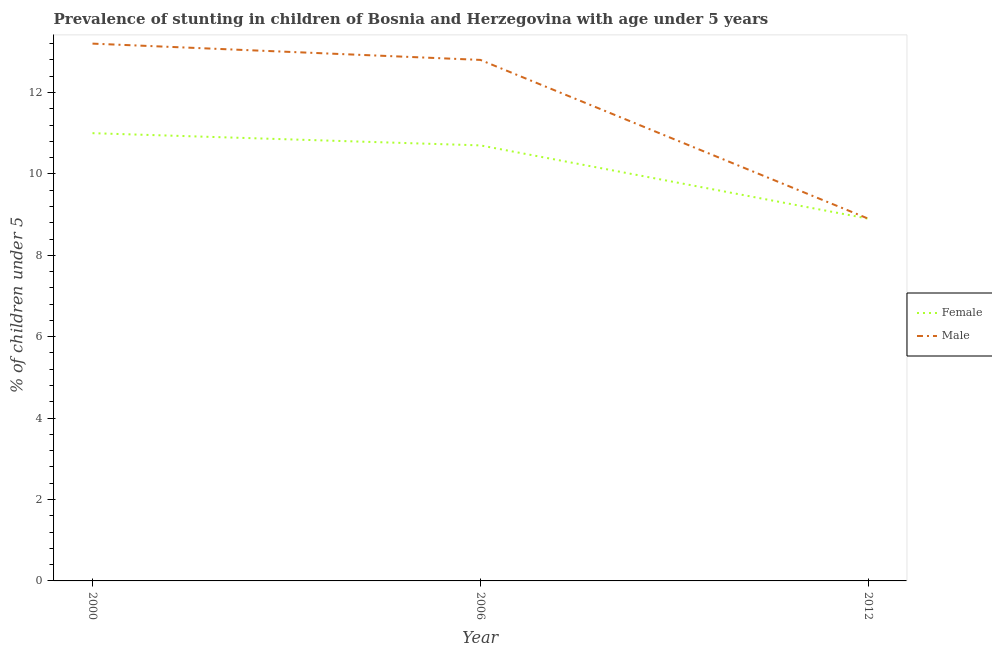Is the number of lines equal to the number of legend labels?
Provide a short and direct response. Yes. What is the percentage of stunted male children in 2012?
Provide a succinct answer. 8.9. Across all years, what is the maximum percentage of stunted male children?
Your answer should be compact. 13.2. Across all years, what is the minimum percentage of stunted male children?
Give a very brief answer. 8.9. In which year was the percentage of stunted female children minimum?
Ensure brevity in your answer.  2012. What is the total percentage of stunted male children in the graph?
Keep it short and to the point. 34.9. What is the difference between the percentage of stunted female children in 2000 and that in 2006?
Make the answer very short. 0.3. What is the difference between the percentage of stunted female children in 2012 and the percentage of stunted male children in 2000?
Your response must be concise. -4.3. What is the average percentage of stunted female children per year?
Provide a short and direct response. 10.2. In the year 2012, what is the difference between the percentage of stunted female children and percentage of stunted male children?
Your answer should be very brief. 0. In how many years, is the percentage of stunted female children greater than 2 %?
Make the answer very short. 3. What is the ratio of the percentage of stunted female children in 2000 to that in 2006?
Keep it short and to the point. 1.03. What is the difference between the highest and the second highest percentage of stunted female children?
Provide a succinct answer. 0.3. What is the difference between the highest and the lowest percentage of stunted female children?
Keep it short and to the point. 2.1. Is the sum of the percentage of stunted female children in 2000 and 2006 greater than the maximum percentage of stunted male children across all years?
Offer a terse response. Yes. Is the percentage of stunted male children strictly greater than the percentage of stunted female children over the years?
Offer a terse response. No. Is the percentage of stunted female children strictly less than the percentage of stunted male children over the years?
Make the answer very short. No. How many lines are there?
Make the answer very short. 2. Does the graph contain any zero values?
Keep it short and to the point. No. Does the graph contain grids?
Provide a succinct answer. No. Where does the legend appear in the graph?
Your response must be concise. Center right. How many legend labels are there?
Provide a succinct answer. 2. How are the legend labels stacked?
Your answer should be very brief. Vertical. What is the title of the graph?
Offer a very short reply. Prevalence of stunting in children of Bosnia and Herzegovina with age under 5 years. Does "Forest" appear as one of the legend labels in the graph?
Offer a very short reply. No. What is the label or title of the Y-axis?
Your answer should be compact.  % of children under 5. What is the  % of children under 5 in Male in 2000?
Keep it short and to the point. 13.2. What is the  % of children under 5 in Female in 2006?
Your answer should be compact. 10.7. What is the  % of children under 5 in Male in 2006?
Provide a short and direct response. 12.8. What is the  % of children under 5 of Female in 2012?
Offer a terse response. 8.9. What is the  % of children under 5 of Male in 2012?
Make the answer very short. 8.9. Across all years, what is the maximum  % of children under 5 in Male?
Keep it short and to the point. 13.2. Across all years, what is the minimum  % of children under 5 in Female?
Offer a very short reply. 8.9. Across all years, what is the minimum  % of children under 5 of Male?
Provide a succinct answer. 8.9. What is the total  % of children under 5 of Female in the graph?
Ensure brevity in your answer.  30.6. What is the total  % of children under 5 of Male in the graph?
Provide a succinct answer. 34.9. What is the difference between the  % of children under 5 of Male in 2000 and that in 2012?
Keep it short and to the point. 4.3. What is the difference between the  % of children under 5 of Female in 2006 and that in 2012?
Make the answer very short. 1.8. What is the difference between the  % of children under 5 of Male in 2006 and that in 2012?
Offer a very short reply. 3.9. What is the difference between the  % of children under 5 in Female in 2000 and the  % of children under 5 in Male in 2006?
Offer a very short reply. -1.8. What is the average  % of children under 5 in Female per year?
Ensure brevity in your answer.  10.2. What is the average  % of children under 5 of Male per year?
Provide a succinct answer. 11.63. In the year 2000, what is the difference between the  % of children under 5 of Female and  % of children under 5 of Male?
Your answer should be compact. -2.2. What is the ratio of the  % of children under 5 in Female in 2000 to that in 2006?
Keep it short and to the point. 1.03. What is the ratio of the  % of children under 5 of Male in 2000 to that in 2006?
Your response must be concise. 1.03. What is the ratio of the  % of children under 5 in Female in 2000 to that in 2012?
Provide a short and direct response. 1.24. What is the ratio of the  % of children under 5 in Male in 2000 to that in 2012?
Offer a very short reply. 1.48. What is the ratio of the  % of children under 5 in Female in 2006 to that in 2012?
Offer a terse response. 1.2. What is the ratio of the  % of children under 5 in Male in 2006 to that in 2012?
Your answer should be compact. 1.44. 